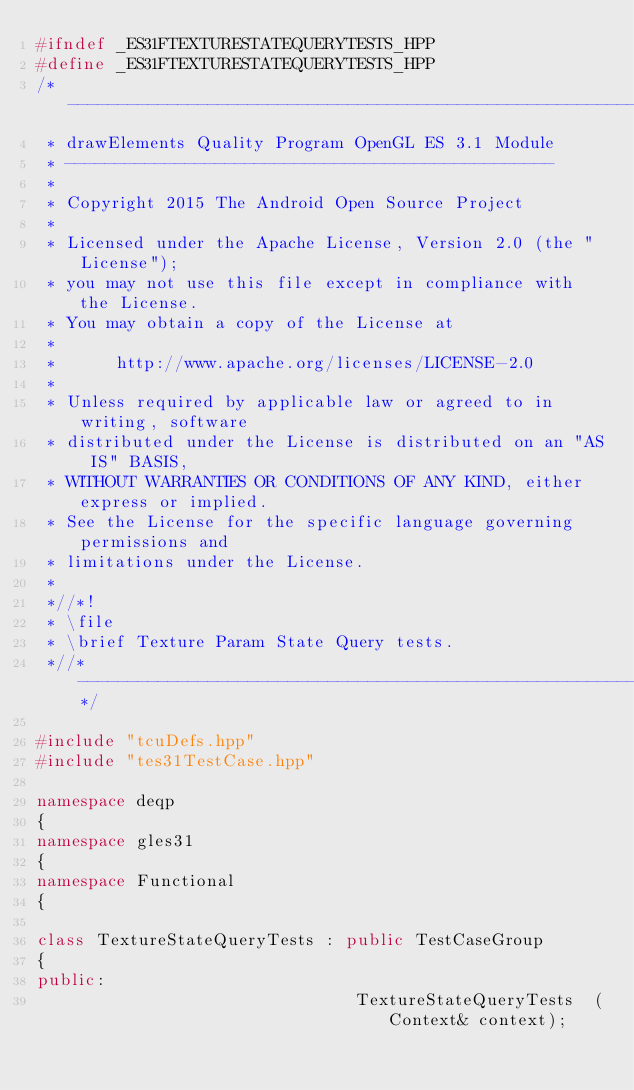<code> <loc_0><loc_0><loc_500><loc_500><_C++_>#ifndef _ES31FTEXTURESTATEQUERYTESTS_HPP
#define _ES31FTEXTURESTATEQUERYTESTS_HPP
/*-------------------------------------------------------------------------
 * drawElements Quality Program OpenGL ES 3.1 Module
 * -------------------------------------------------
 *
 * Copyright 2015 The Android Open Source Project
 *
 * Licensed under the Apache License, Version 2.0 (the "License");
 * you may not use this file except in compliance with the License.
 * You may obtain a copy of the License at
 *
 *      http://www.apache.org/licenses/LICENSE-2.0
 *
 * Unless required by applicable law or agreed to in writing, software
 * distributed under the License is distributed on an "AS IS" BASIS,
 * WITHOUT WARRANTIES OR CONDITIONS OF ANY KIND, either express or implied.
 * See the License for the specific language governing permissions and
 * limitations under the License.
 *
 *//*!
 * \file
 * \brief Texture Param State Query tests.
 *//*--------------------------------------------------------------------*/

#include "tcuDefs.hpp"
#include "tes31TestCase.hpp"

namespace deqp
{
namespace gles31
{
namespace Functional
{

class TextureStateQueryTests : public TestCaseGroup
{
public:
								TextureStateQueryTests	(Context& context);</code> 